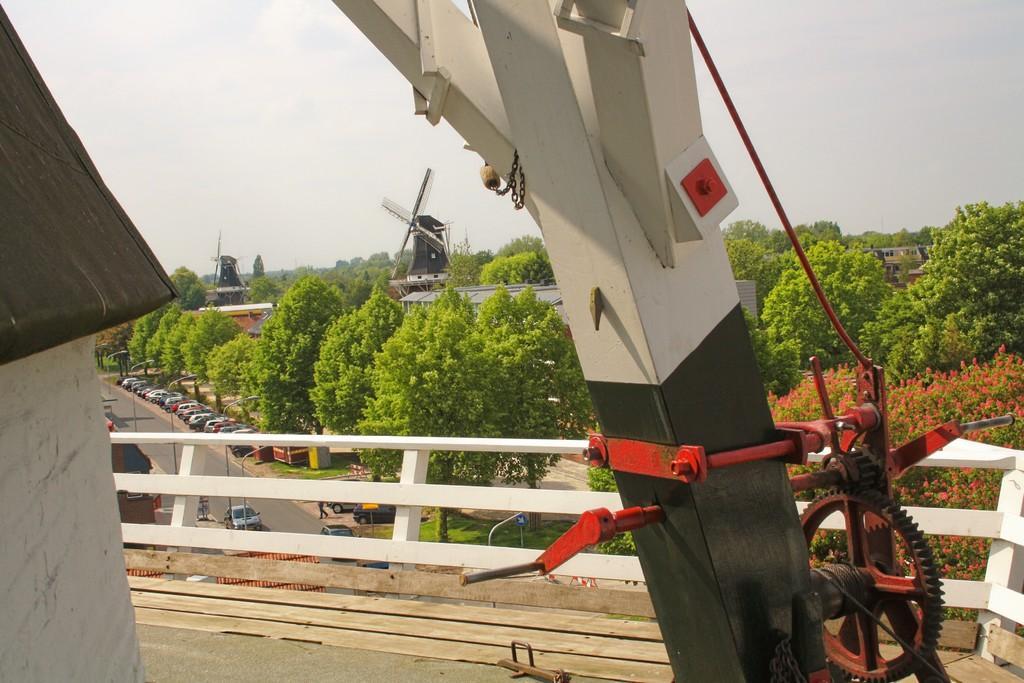Describe this image in one or two sentences. In the picture we can see from the windmill with a pole and railing and from it we can see the road with some vehicles and trees and in the background we can see two windmills and the sky. 